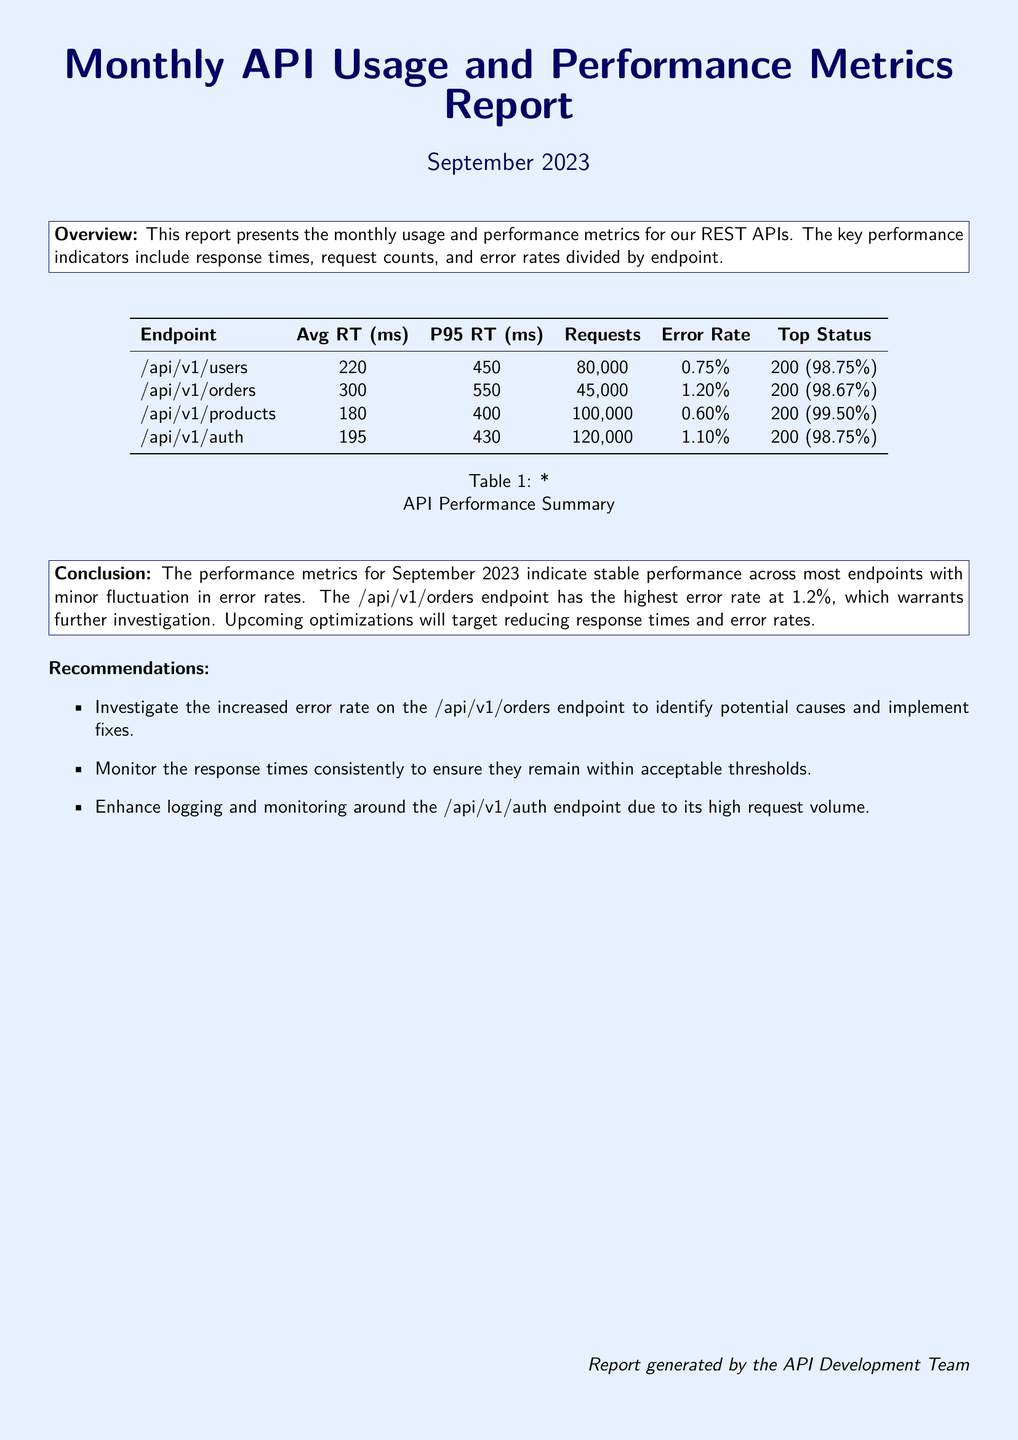What is the average response time for the /api/v1/users endpoint? The average response time for the /api/v1/users endpoint is listed in the table under Avg RT (ms).
Answer: 220 ms What was the total number of requests for the /api/v1/products endpoint? The total number of requests for the /api/v1/products endpoint can be found in the Requests column of the table.
Answer: 100,000 Which endpoint has the highest error rate? The endpoint with the highest error rate is indicated in the Error Rate column of the table.
Answer: /api/v1/orders What is the P95 response time for the /api/v1/auth endpoint? The P95 response time for the /api/v1/auth endpoint is provided in the P95 RT (ms) column of the table.
Answer: 430 ms What percentage of requests to the /api/v1/products endpoint returned a status of 200? The status information is summarized in the Top Status column of the table, showing the percentage of successful requests.
Answer: 99.50% What conclusion does the report draw about the performance metrics for September 2023? The conclusion can be found in the Conclusion section, summarizing the performance and areas for improvement.
Answer: Stable performance What is one recommendation made for the /api/v1/orders endpoint? A recommendation is detailed in the Recommendations section, specifically focusing on the /api/v1/orders endpoint's error rate.
Answer: Investigate the increased error rate How many total endpoints are analyzed in this report? The number of endpoints can be counted from the rows in the table.
Answer: Four When was the report generated? The date of the report is mentioned at the top of the document in the title.
Answer: September 2023 What performance issue is highlighted for the /api/v1/orders endpoint? The specific performance issue is noted in the Error Rate section of the table.
Answer: Highest error rate at 1.2% 